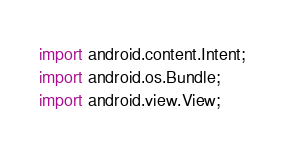Convert code to text. <code><loc_0><loc_0><loc_500><loc_500><_Java_>import android.content.Intent;
import android.os.Bundle;
import android.view.View;
</code> 